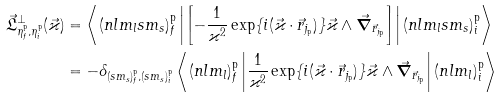Convert formula to latex. <formula><loc_0><loc_0><loc_500><loc_500>\vec { \mathfrak { L } } _ { \eta _ { f } ^ { \mathrm p } , \eta _ { i } ^ { \mathrm p } } ^ { \bot } ( \vec { \varkappa } ) & = \left \langle ( n l m _ { l } s m _ { s } ) _ { f } ^ { \mathrm p } \left | \left [ - \frac { 1 } { \varkappa ^ { 2 } } \exp \{ i ( \vec { \varkappa } \cdot \vec { r } _ { j _ { \mathrm p } } ) \} \vec { \varkappa } \wedge \vec { \boldsymbol \nabla } _ { \vec { r } _ { j _ { \mathrm p } } } \right ] \right | ( n l m _ { l } s m _ { s } ) _ { i } ^ { \mathrm p } \right \rangle \\ & = - \delta _ { ( s m _ { s } ) _ { f } ^ { \mathrm p } , ( s m _ { s } ) _ { i } ^ { \mathrm p } } \left \langle ( n l m _ { l } ) _ { f } ^ { \mathrm p } \left | \frac { 1 } { \varkappa ^ { 2 } } \exp \{ i ( \vec { \varkappa } \cdot \vec { r } _ { j _ { \mathrm p } } ) \} \vec { \varkappa } \wedge \vec { \boldsymbol \nabla } _ { \vec { r } _ { j _ { \mathrm p } } } \right | ( n l m _ { l } ) _ { i } ^ { \mathrm p } \right \rangle</formula> 